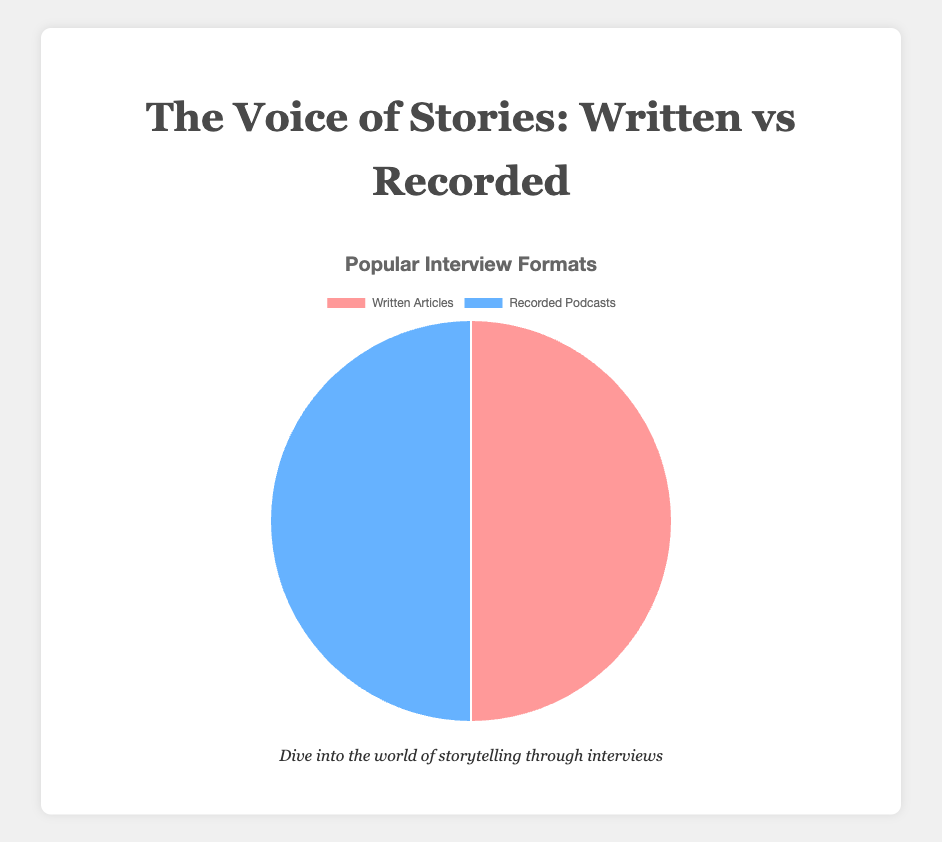What is the ratio of Written Articles to Recorded Podcasts? Based on the pie chart, both Written Articles and Recorded Podcasts are represented equally because they each occupy half of the pie. Therefore, the ratio of Written Articles to Recorded Podcasts is 1:1.
Answer: 1:1 Which interview format is more popular, Written Articles or Recorded Podcasts? The pie chart shows that both Written Articles and Recorded Podcasts are equally popular as they each take 50% of the pie chart.
Answer: They are equally popular If we sum the contributions of Written Articles and add them to the contributions of Recorded Podcasts, what is the total? The total for both categories, Written Articles (NYT: 40, WP: 30, Guardian: 25, BuzzFeed: 5) and Recorded Podcasts (Daily: 35, NPR: 30, Rogan: 20, TED Talks: 15), is calculated by adding all individual contributions: 40 + 30 + 25 + 5 + 35 + 30 + 20 + 15 = 200.
Answer: 200 Are Written Articles or Recorded Podcasts represented by the color blue in the pie chart? Visually, the segment for Recorded Podcasts is represented in blue. Written Articles are visually represented in red.
Answer: Recorded Podcasts Calculate the average contribution for a single medium (either Written Articles or Recorded Podcasts) by dividing the sum by the number of representations in that medium. Which medium has a higher average? Written:
(40+30+25+5)/4 = 100/4 = 25
Recorded:
(35+30+20+15)/4 = 100/4 = 25
Both mediums have the same average contribution of 25.
Answer: Both are equal If Written Articles are represented in red, what is the visual proportion of the red section in the pie chart? Each section (Written Articles and Recorded Podcasts) takes up half of the pie chart. Since Written Articles are in red, the red section visually represents 50% of the pie chart.
Answer: 50% If Recorded Podcasts had an additional segment with 10 units, how would the overall balance change in the pie chart? Adding 10 units to Recorded Podcasts results in a total of 110 for Recorded Podcasts. The new total is 110 (Recorded Podcasts) + 100 (Written Articles) = 210. The proportion would then be: Written Articles: 100/210 ≈ 47.6%, Recorded Podcasts: 110/210 ≈ 52.4%.
Answer: Recorded Podcasts would be more 